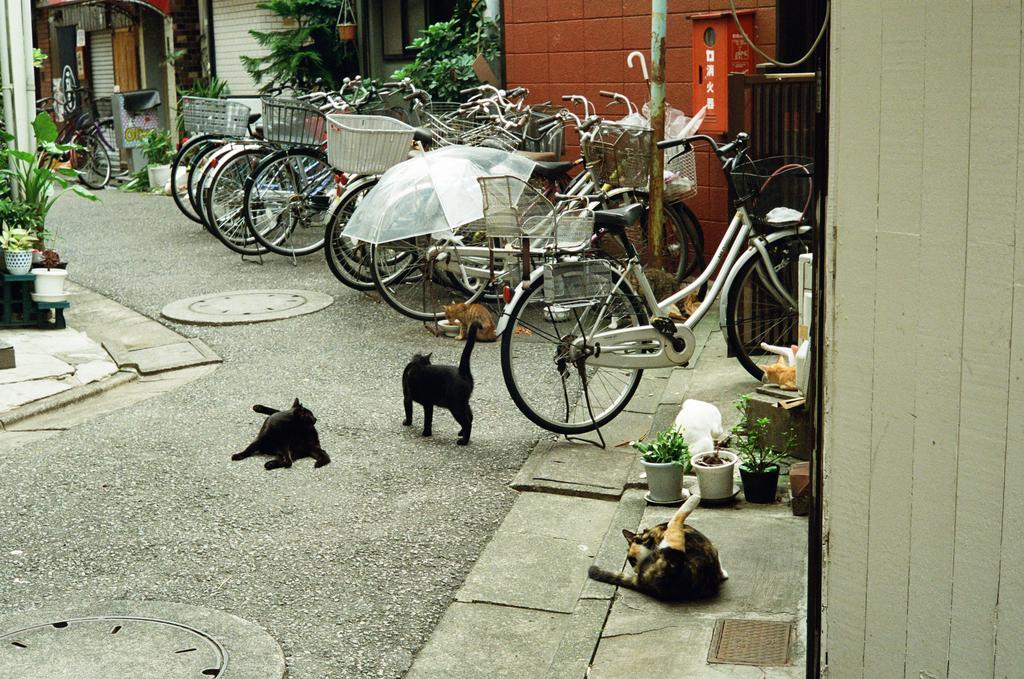Describe this image in one or two sentences. This image consists of many cats sitting and lying on the floor. At the bottom, there is a road. In the front, there are many bicycles parked. On the left and right, there are small plants and houses. 